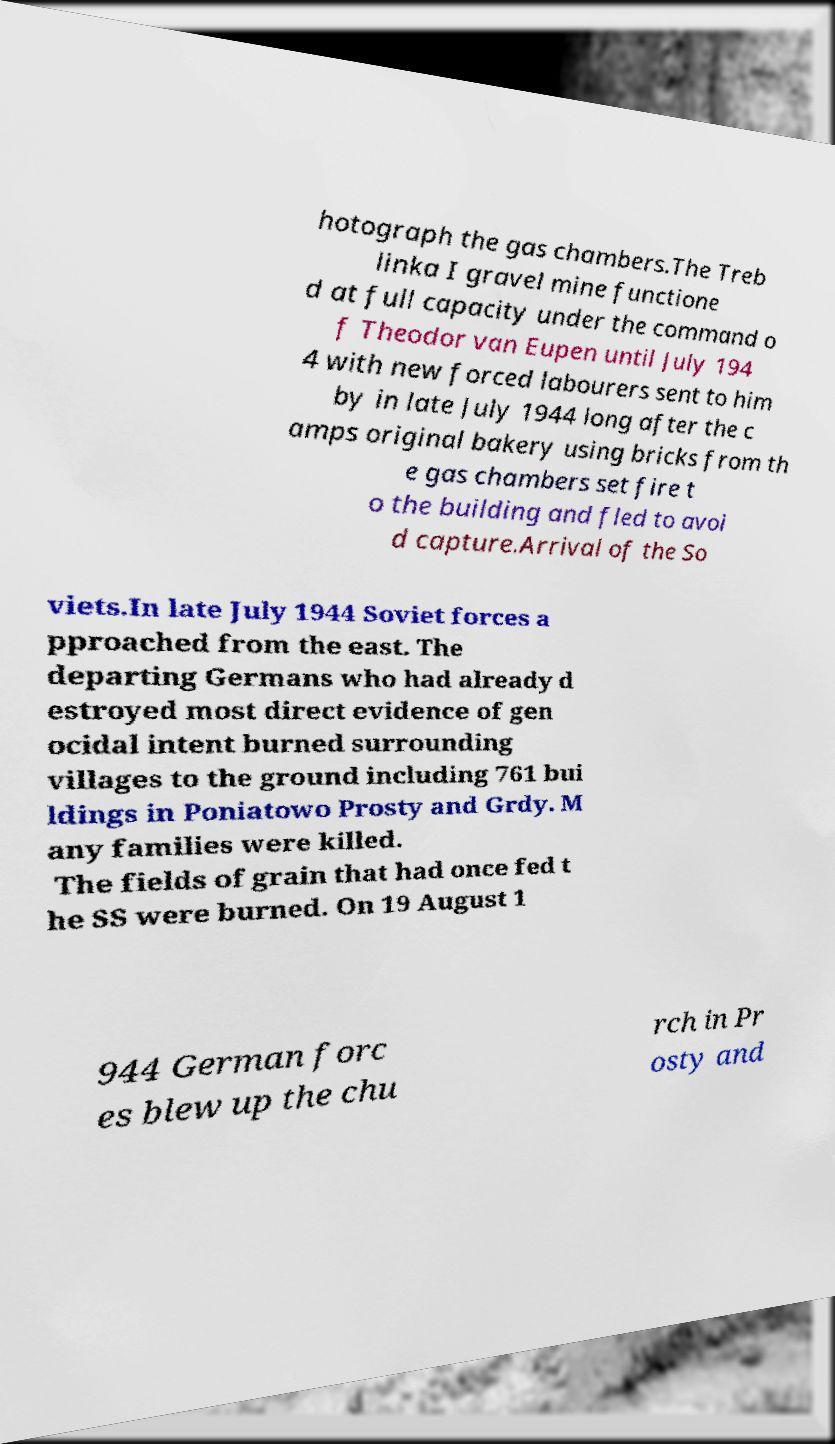Please identify and transcribe the text found in this image. hotograph the gas chambers.The Treb linka I gravel mine functione d at full capacity under the command o f Theodor van Eupen until July 194 4 with new forced labourers sent to him by in late July 1944 long after the c amps original bakery using bricks from th e gas chambers set fire t o the building and fled to avoi d capture.Arrival of the So viets.In late July 1944 Soviet forces a pproached from the east. The departing Germans who had already d estroyed most direct evidence of gen ocidal intent burned surrounding villages to the ground including 761 bui ldings in Poniatowo Prosty and Grdy. M any families were killed. The fields of grain that had once fed t he SS were burned. On 19 August 1 944 German forc es blew up the chu rch in Pr osty and 